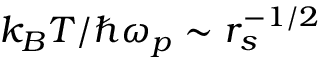Convert formula to latex. <formula><loc_0><loc_0><loc_500><loc_500>k _ { B } T / \hbar { \omega } _ { p } \sim r _ { s } ^ { - 1 / 2 }</formula> 